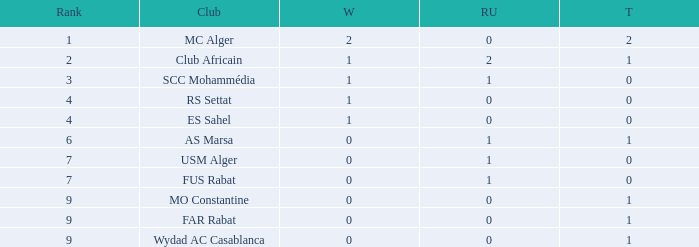Which Winners is the highest one that has a Rank larger than 7, and a Third smaller than 1? None. 